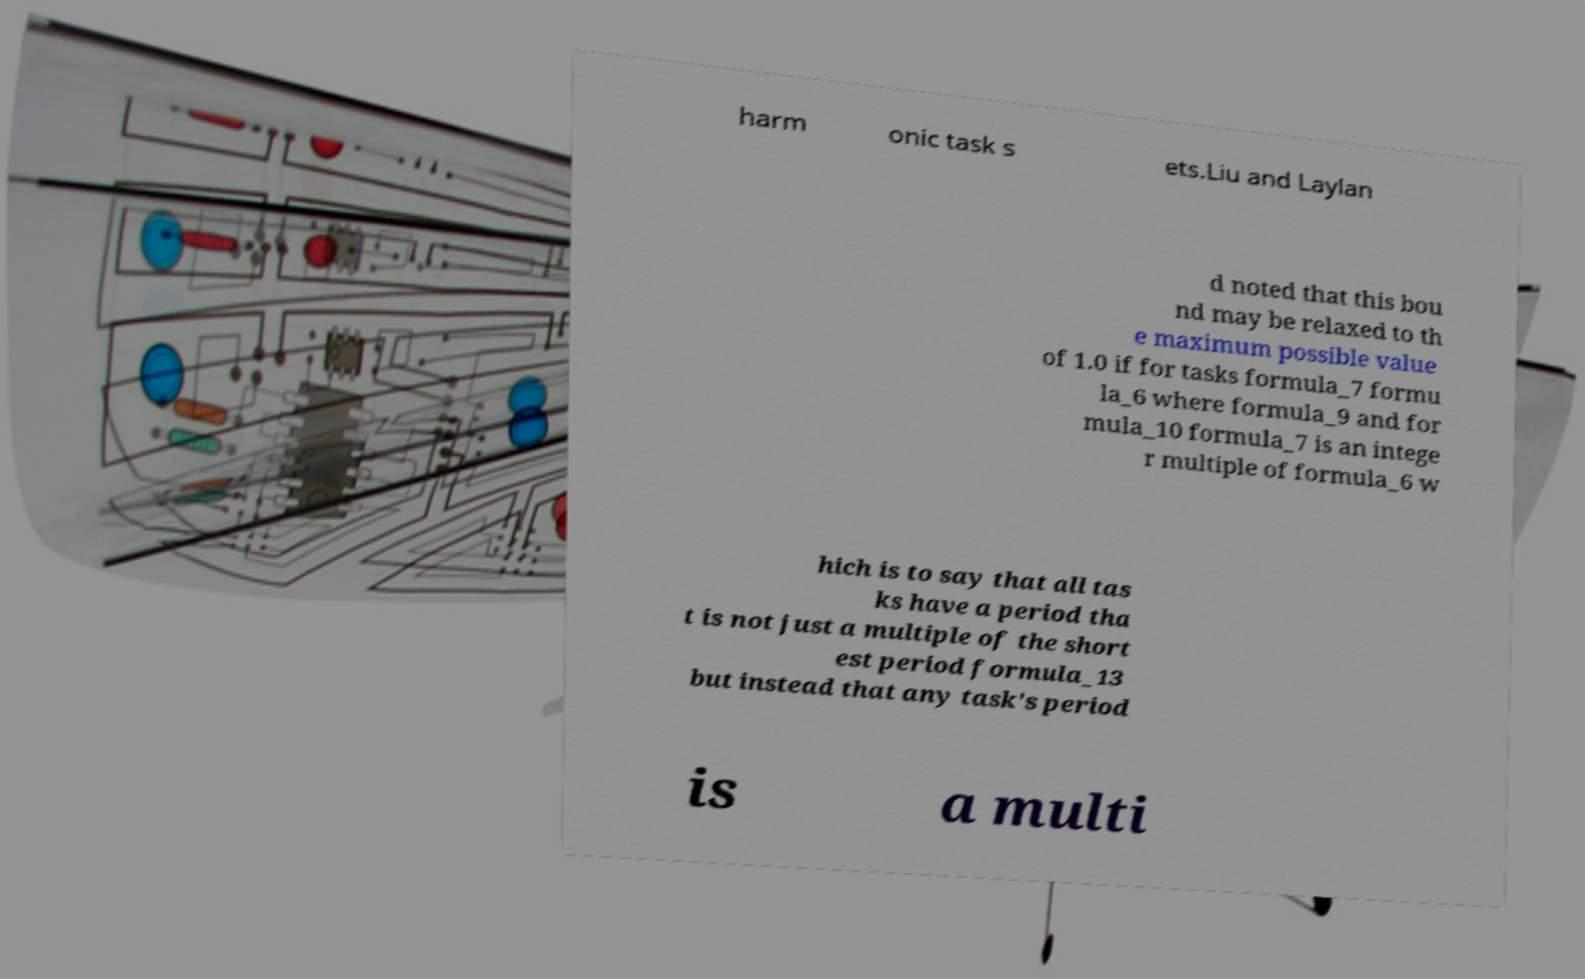Can you accurately transcribe the text from the provided image for me? harm onic task s ets.Liu and Laylan d noted that this bou nd may be relaxed to th e maximum possible value of 1.0 if for tasks formula_7 formu la_6 where formula_9 and for mula_10 formula_7 is an intege r multiple of formula_6 w hich is to say that all tas ks have a period tha t is not just a multiple of the short est period formula_13 but instead that any task's period is a multi 